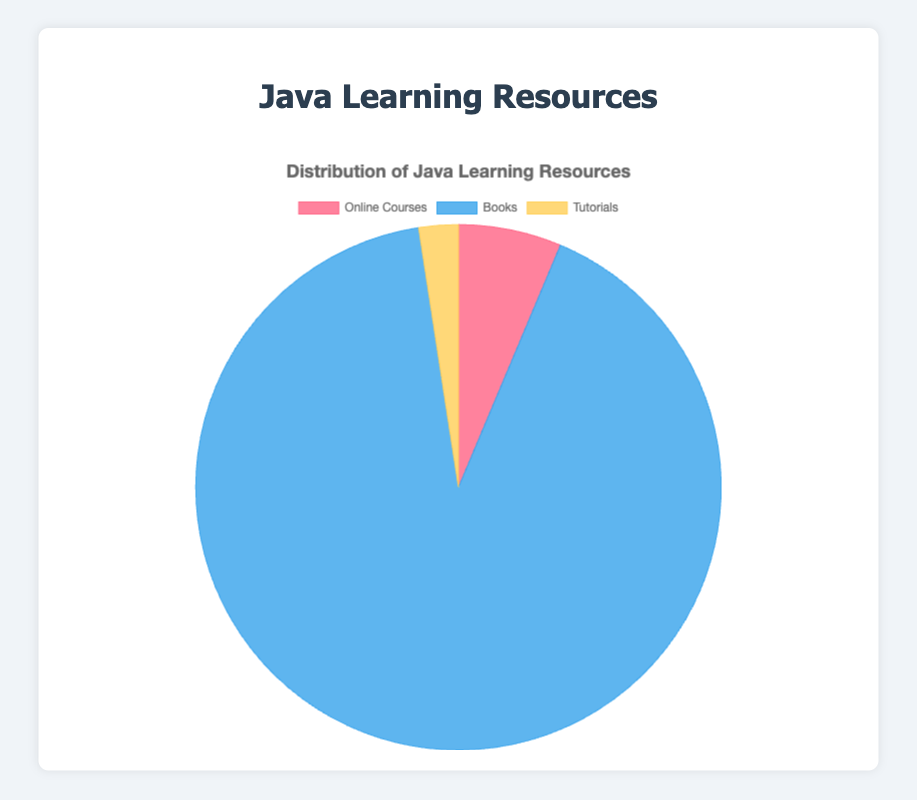Which category has the smallest total value? We need to compare the total values for Online Courses (165 hours), Books (2372 pages), and Tutorials (63 sections). The smallest total value is 63 sections for Tutorials.
Answer: Tutorials How many more pages do Books have compared to hours for Online Courses? We subtract the total hours of Online Courses (165) from the total pages of Books (2372). The difference is \(2372 - 165 = 2207\).
Answer: 2207 What is the average number of sections for Tutorials? To find the average, sum the total sections (63) and divide by the number of tutorial sources (3). The average is \(63 / 3 = 21\) sections.
Answer: 21 sections Which category is displayed in blue? Observing the visual attributes, the segment represented by blue corresponds to Books.
Answer: Books How much time in total is spent on Online Courses? The total hours for Online Courses are given as 165 hours in the dataset.
Answer: 165 hours Which category dominates the pie chart visually? The largest segment visually is the one with the most significant value, which corresponds to Books with 2372 pages.
Answer: Books What's the percentage distribution of Online Courses in the pie chart? To find the percentage, divide the total hours of Online Courses (165) by the sum of all values (165 + 2372 + 63), then multiply by 100. The total sum is \(2600\); thus, the percentage for Online Courses is \((165 / 2600) * 100 ≈ 6.35\%\).
Answer: 6.35% What is the combined total of hours and sections for Online Courses and Tutorials? We add the total hours for Online Courses (165) and the total sections for Tutorials (63). The combined total is \(165 + 63 = 228\).
Answer: 228 What's the sum of pages from Books and hours from Online Courses? We add the total pages of Books (2372) and the total hours of Online Courses (165). The sum is \(2372 + 165 = 2537\).
Answer: 2537 